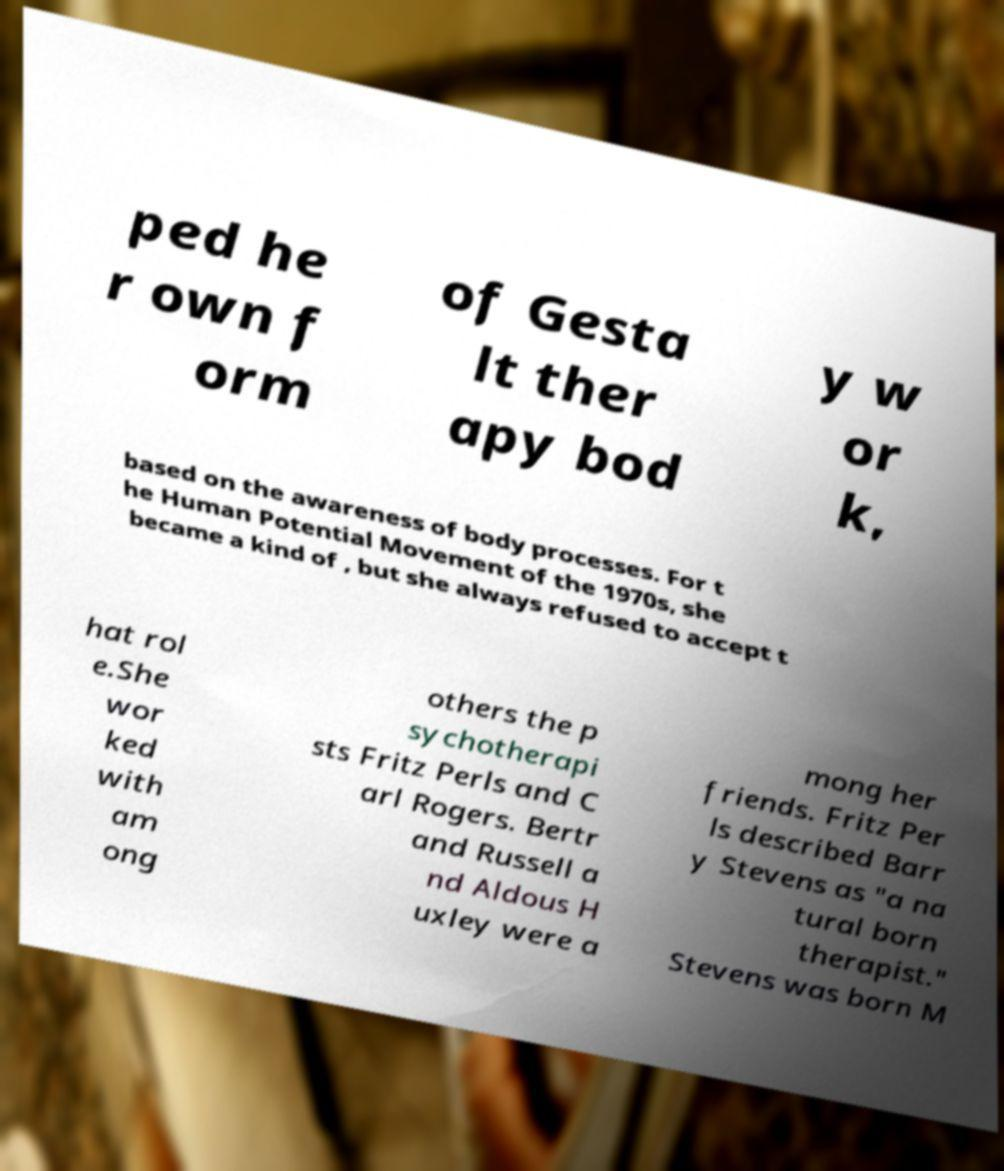Please read and relay the text visible in this image. What does it say? ped he r own f orm of Gesta lt ther apy bod y w or k, based on the awareness of body processes. For t he Human Potential Movement of the 1970s, she became a kind of , but she always refused to accept t hat rol e.She wor ked with am ong others the p sychotherapi sts Fritz Perls and C arl Rogers. Bertr and Russell a nd Aldous H uxley were a mong her friends. Fritz Per ls described Barr y Stevens as "a na tural born therapist." Stevens was born M 